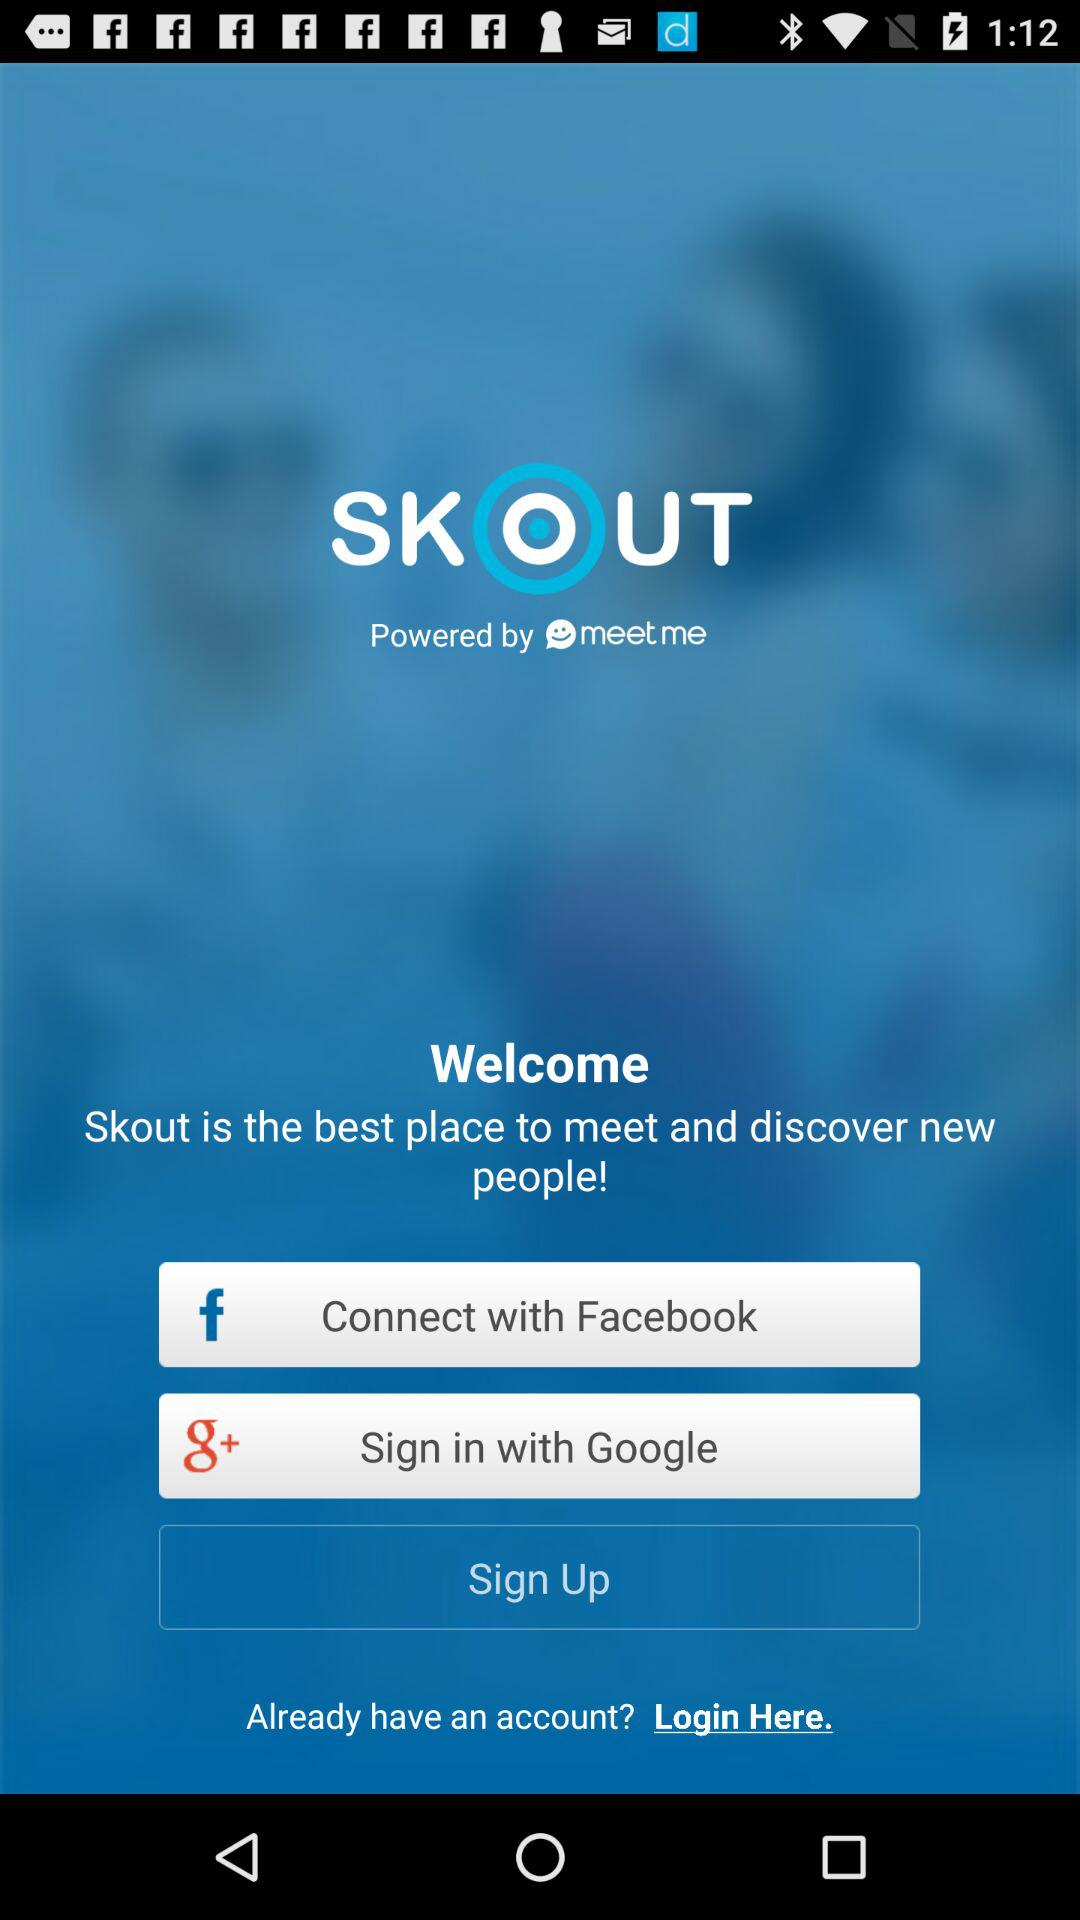Skout is powered by which company? Skout is powered by meet me. 